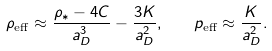Convert formula to latex. <formula><loc_0><loc_0><loc_500><loc_500>\rho _ { \text {eff} } \approx \frac { \rho _ { * } - 4 C } { a _ { D } ^ { 3 } } - \frac { 3 K } { a _ { D } ^ { 2 } } , \quad p _ { \text {eff} } \approx \frac { K } { a _ { D } ^ { 2 } } .</formula> 